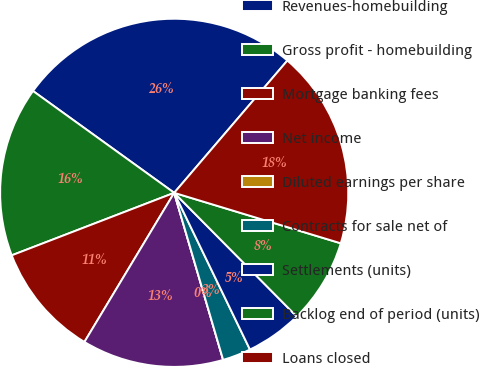Convert chart. <chart><loc_0><loc_0><loc_500><loc_500><pie_chart><fcel>Revenues-homebuilding<fcel>Gross profit - homebuilding<fcel>Mortgage banking fees<fcel>Net income<fcel>Diluted earnings per share<fcel>Contracts for sale net of<fcel>Settlements (units)<fcel>Backlog end of period (units)<fcel>Loans closed<nl><fcel>26.32%<fcel>15.79%<fcel>10.53%<fcel>13.16%<fcel>0.0%<fcel>2.63%<fcel>5.26%<fcel>7.89%<fcel>18.42%<nl></chart> 